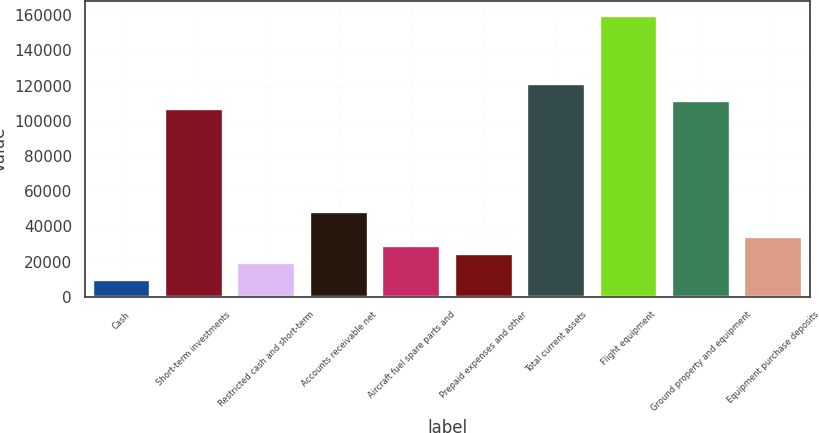<chart> <loc_0><loc_0><loc_500><loc_500><bar_chart><fcel>Cash<fcel>Short-term investments<fcel>Restricted cash and short-term<fcel>Accounts receivable net<fcel>Aircraft fuel spare parts and<fcel>Prepaid expenses and other<fcel>Total current assets<fcel>Flight equipment<fcel>Ground property and equipment<fcel>Equipment purchase deposits<nl><fcel>9687.8<fcel>106506<fcel>19369.6<fcel>48415<fcel>29051.4<fcel>24210.5<fcel>121028<fcel>159756<fcel>111347<fcel>33892.3<nl></chart> 